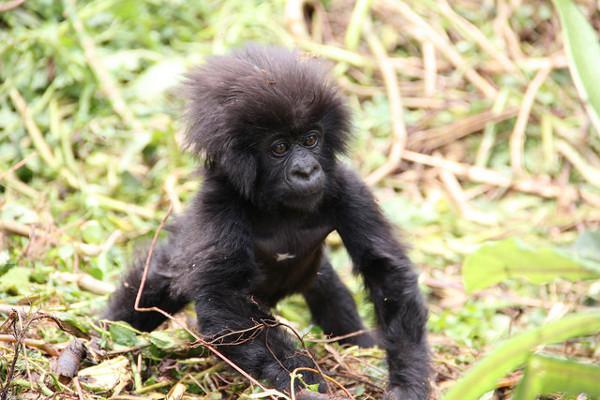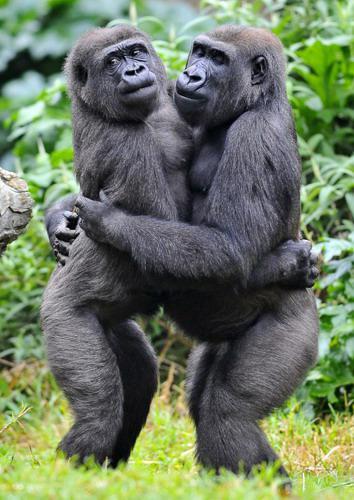The first image is the image on the left, the second image is the image on the right. Assess this claim about the two images: "An image shows two gorillas of similar size posed close together, with bodies facing each other.". Correct or not? Answer yes or no. Yes. The first image is the image on the left, the second image is the image on the right. Examine the images to the left and right. Is the description "There are four gorillas with two pairs touching one another." accurate? Answer yes or no. No. 